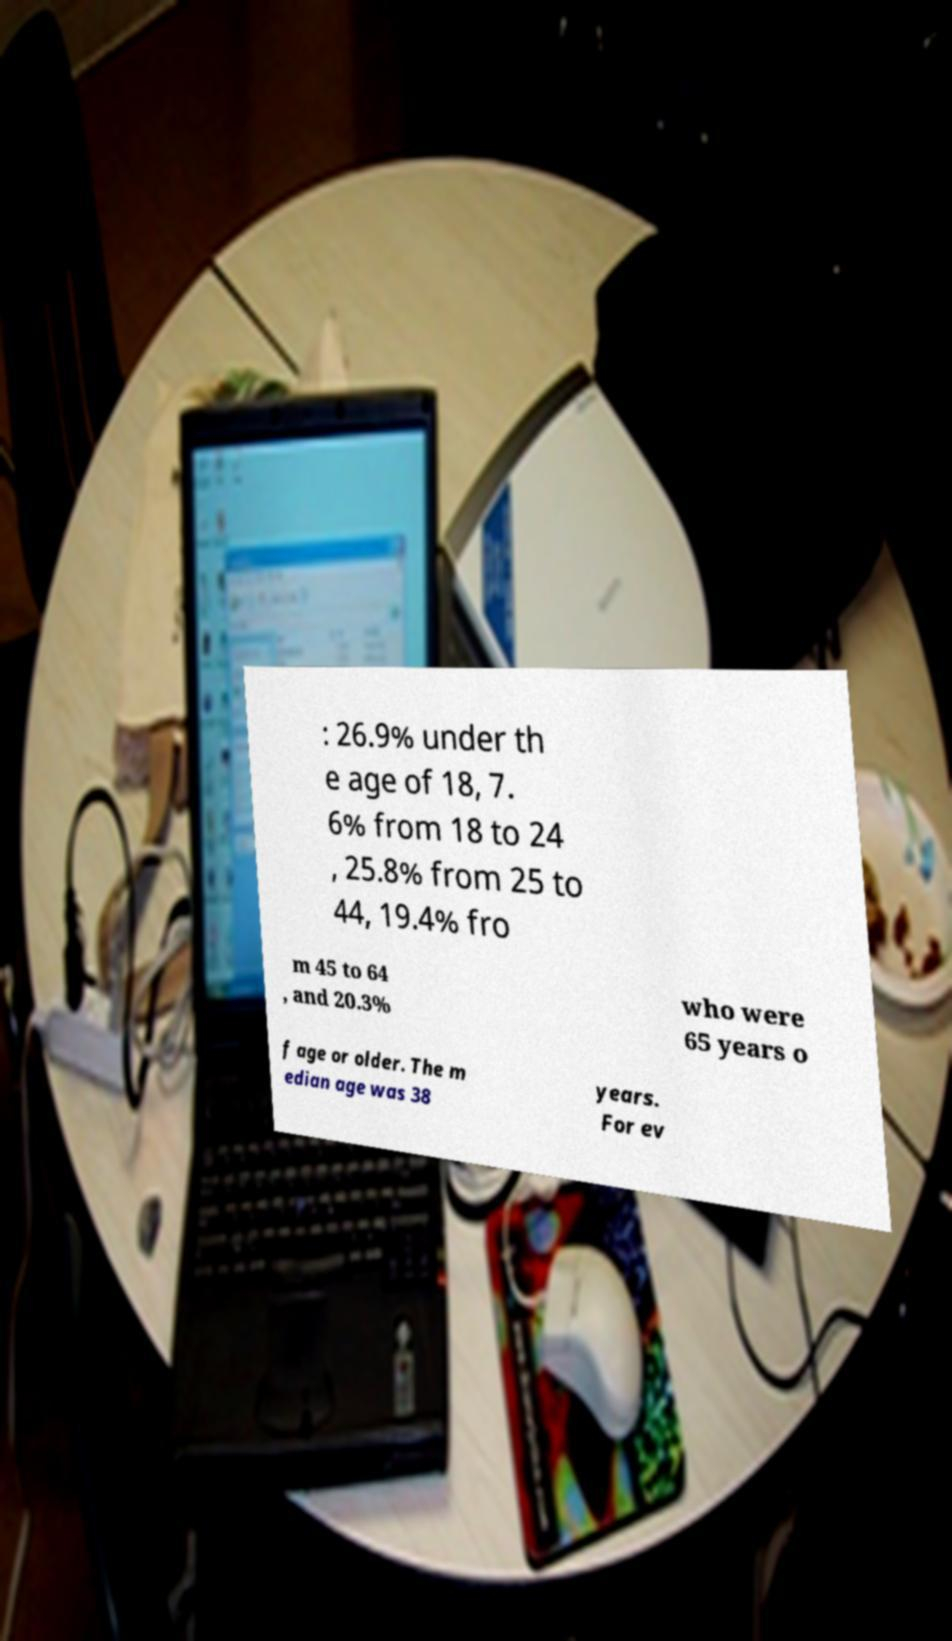Please identify and transcribe the text found in this image. : 26.9% under th e age of 18, 7. 6% from 18 to 24 , 25.8% from 25 to 44, 19.4% fro m 45 to 64 , and 20.3% who were 65 years o f age or older. The m edian age was 38 years. For ev 